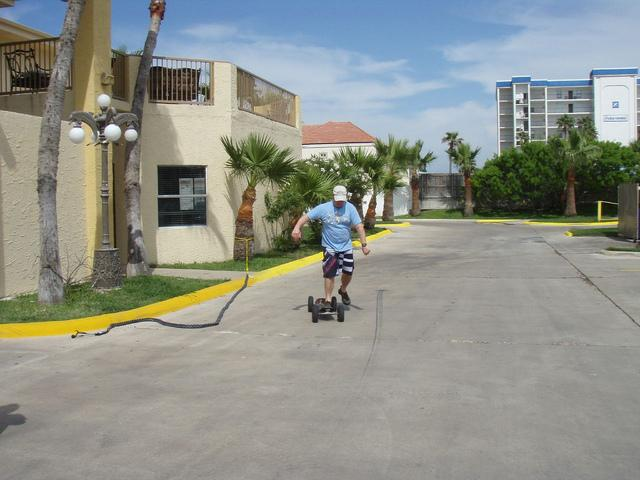What is unusual about the man's skateboard? Please explain your reasoning. big wheels. Skateboards usually have small wheels, this one has rather big wheels making it look weird. 